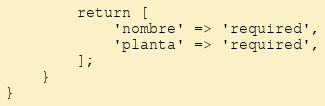<code> <loc_0><loc_0><loc_500><loc_500><_PHP_>        return [
            'nombre' => 'required',
            'planta' => 'required',
        ];
    }
}
</code> 